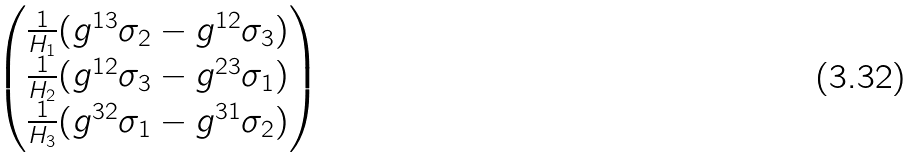Convert formula to latex. <formula><loc_0><loc_0><loc_500><loc_500>\begin{pmatrix} \frac { 1 } { H _ { 1 } } ( g ^ { 1 3 } \sigma _ { 2 } - g ^ { 1 2 } \sigma _ { 3 } ) \\ \frac { 1 } { H _ { 2 } } ( g ^ { 1 2 } \sigma _ { 3 } - g ^ { 2 3 } \sigma _ { 1 } ) \\ \frac { 1 } { H _ { 3 } } ( g ^ { 3 2 } \sigma _ { 1 } - g ^ { 3 1 } \sigma _ { 2 } ) \end{pmatrix}</formula> 